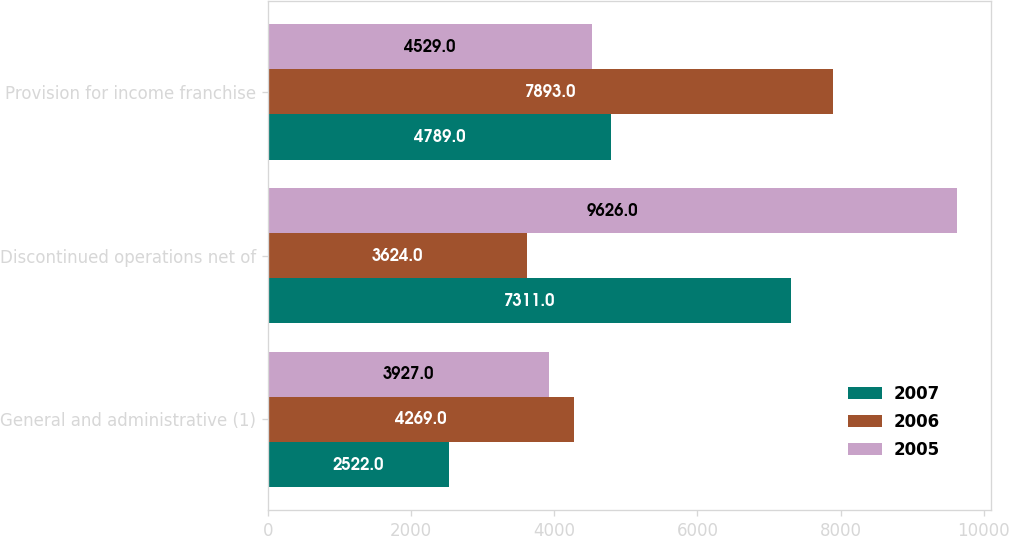Convert chart to OTSL. <chart><loc_0><loc_0><loc_500><loc_500><stacked_bar_chart><ecel><fcel>General and administrative (1)<fcel>Discontinued operations net of<fcel>Provision for income franchise<nl><fcel>2007<fcel>2522<fcel>7311<fcel>4789<nl><fcel>2006<fcel>4269<fcel>3624<fcel>7893<nl><fcel>2005<fcel>3927<fcel>9626<fcel>4529<nl></chart> 